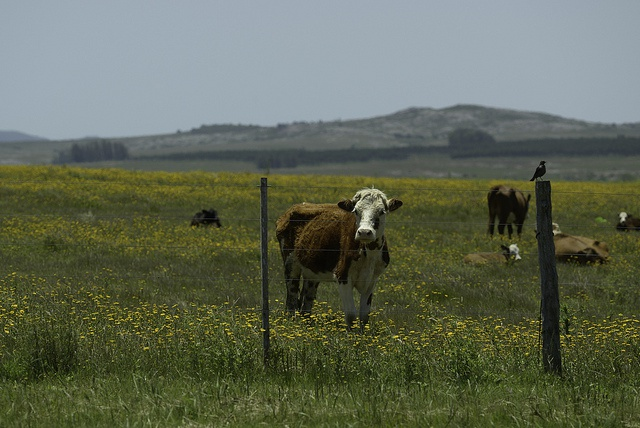Describe the objects in this image and their specific colors. I can see cow in darkgray, black, darkgreen, and gray tones, cow in darkgray, black, darkgreen, and gray tones, cow in darkgray, black, and olive tones, cow in darkgray, darkgreen, black, and gray tones, and cow in darkgray, black, gray, and darkgreen tones in this image. 